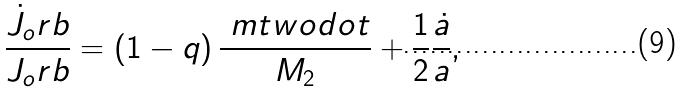Convert formula to latex. <formula><loc_0><loc_0><loc_500><loc_500>\frac { \dot { J } _ { o } r b } { J _ { o } r b } = \left ( 1 - q \right ) \frac { \ m t w o d o t } { M _ { 2 } } + \frac { 1 } { 2 } \frac { \dot { a } } { a } ,</formula> 